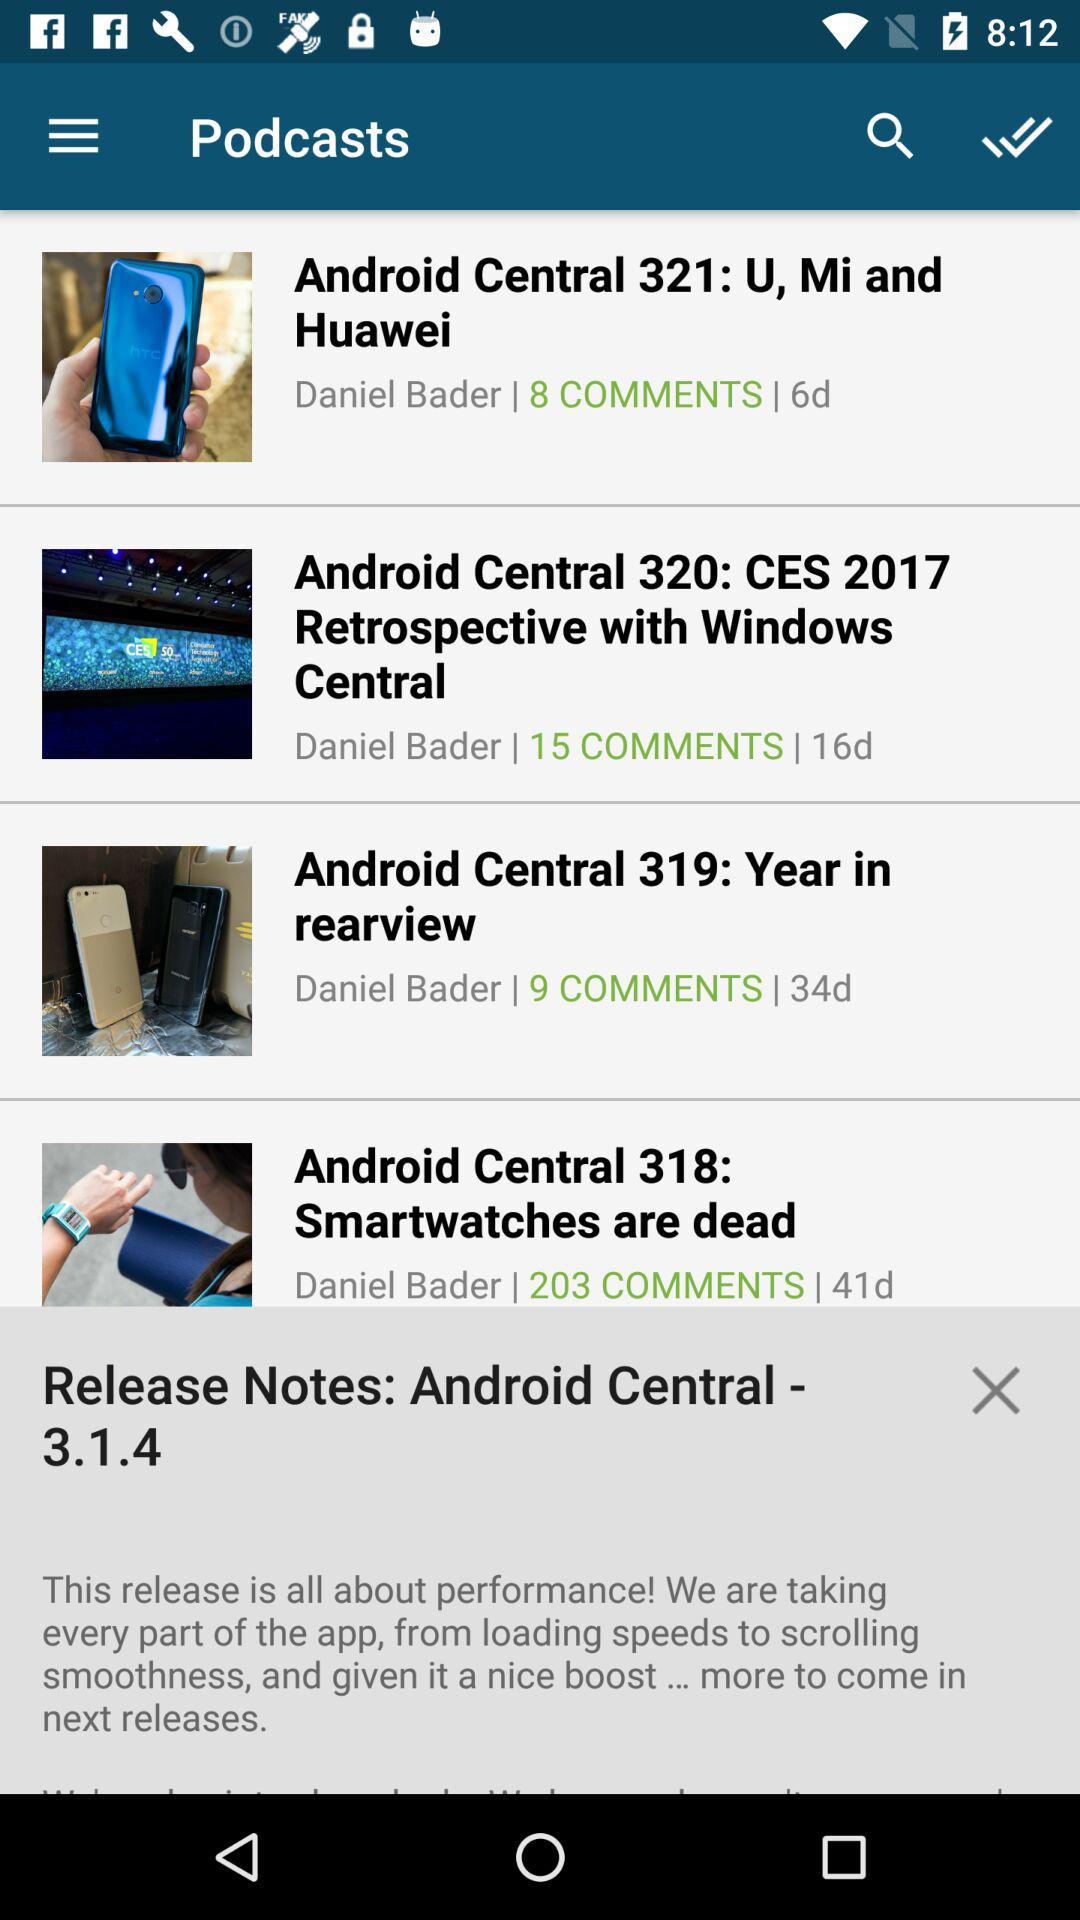What is the first comment on Android Central 321: U, Mi and Huawei?
When the provided information is insufficient, respond with <no answer>. <no answer> 